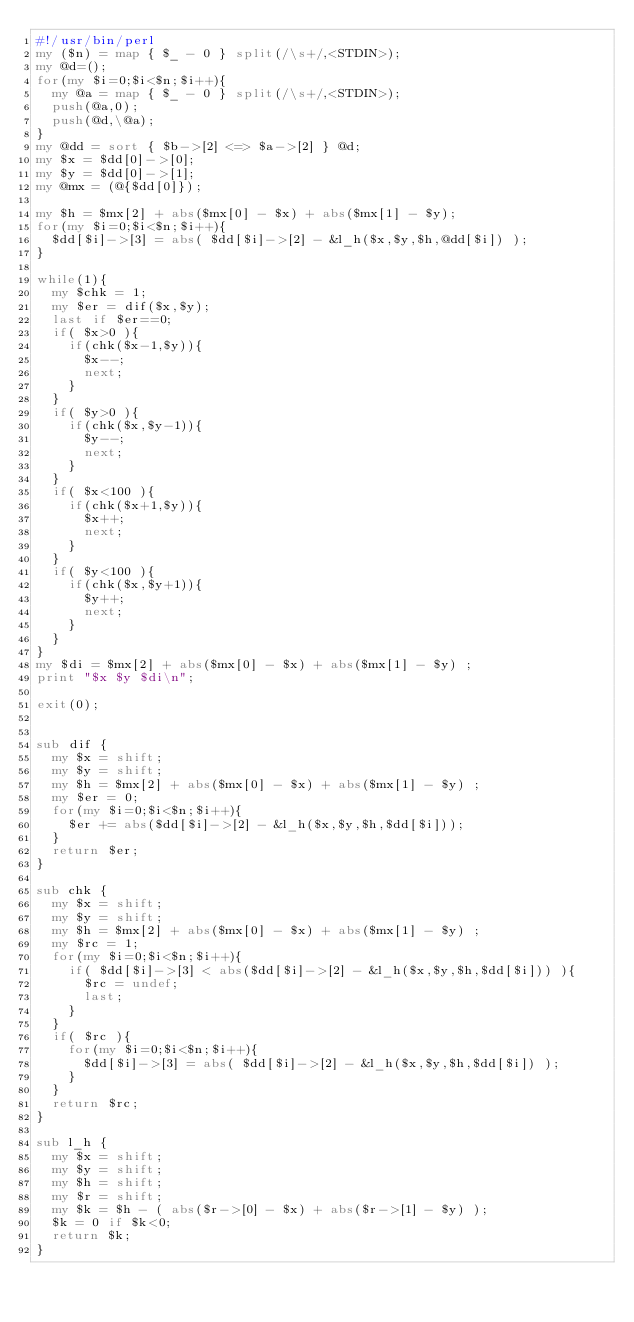Convert code to text. <code><loc_0><loc_0><loc_500><loc_500><_Perl_>#!/usr/bin/perl
my ($n) = map { $_ - 0 } split(/\s+/,<STDIN>);
my @d=();
for(my $i=0;$i<$n;$i++){
  my @a = map { $_ - 0 } split(/\s+/,<STDIN>);
  push(@a,0);
  push(@d,\@a);
}
my @dd = sort { $b->[2] <=> $a->[2] } @d;
my $x = $dd[0]->[0];
my $y = $dd[0]->[1];
my @mx = (@{$dd[0]});

my $h = $mx[2] + abs($mx[0] - $x) + abs($mx[1] - $y);
for(my $i=0;$i<$n;$i++){
  $dd[$i]->[3] = abs( $dd[$i]->[2] - &l_h($x,$y,$h,@dd[$i]) );
}

while(1){
  my $chk = 1;
  my $er = dif($x,$y);
  last if $er==0;
  if( $x>0 ){
    if(chk($x-1,$y)){
      $x--;
      next;
    }
  }
  if( $y>0 ){
    if(chk($x,$y-1)){
      $y--;
      next;
    }
  }
  if( $x<100 ){
    if(chk($x+1,$y)){
      $x++;
      next;
    }
  }
  if( $y<100 ){
    if(chk($x,$y+1)){
      $y++;
      next;
    }
  }
}
my $di = $mx[2] + abs($mx[0] - $x) + abs($mx[1] - $y) ;
print "$x $y $di\n";

exit(0);


sub dif {
  my $x = shift;
  my $y = shift;
  my $h = $mx[2] + abs($mx[0] - $x) + abs($mx[1] - $y) ;
  my $er = 0;
  for(my $i=0;$i<$n;$i++){
    $er += abs($dd[$i]->[2] - &l_h($x,$y,$h,$dd[$i]));
  }
  return $er;
}

sub chk {
  my $x = shift;
  my $y = shift;
  my $h = $mx[2] + abs($mx[0] - $x) + abs($mx[1] - $y) ;
  my $rc = 1;
  for(my $i=0;$i<$n;$i++){
    if( $dd[$i]->[3] < abs($dd[$i]->[2] - &l_h($x,$y,$h,$dd[$i])) ){
      $rc = undef;
      last;
    }
  }
  if( $rc ){
    for(my $i=0;$i<$n;$i++){
      $dd[$i]->[3] = abs( $dd[$i]->[2] - &l_h($x,$y,$h,$dd[$i]) );
    }
  }
  return $rc;
}

sub l_h {
  my $x = shift;
  my $y = shift;
  my $h = shift;
  my $r = shift;
  my $k = $h - ( abs($r->[0] - $x) + abs($r->[1] - $y) );
  $k = 0 if $k<0;
  return $k;
}

</code> 